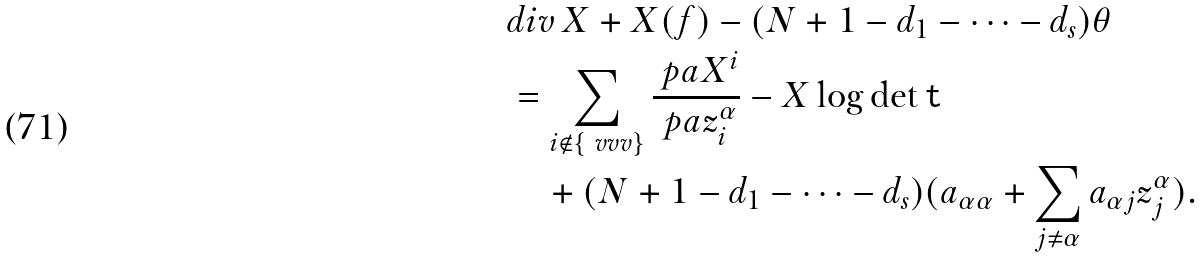Convert formula to latex. <formula><loc_0><loc_0><loc_500><loc_500>& d i v \, X + X ( f ) - ( N + 1 - d _ { 1 } - \cdots - d _ { s } ) \theta \\ & = \sum _ { i \notin \{ \ v v v \} } \frac { \ p a X ^ { i } } { \ p a z _ { i } ^ { \alpha } } - X \log \det \tt t \\ & \quad + ( N + 1 - d _ { 1 } - \cdots - d _ { s } ) ( a _ { \alpha \alpha } + \sum _ { j \neq \alpha } a _ { \alpha j } z _ { j } ^ { \alpha } ) .</formula> 